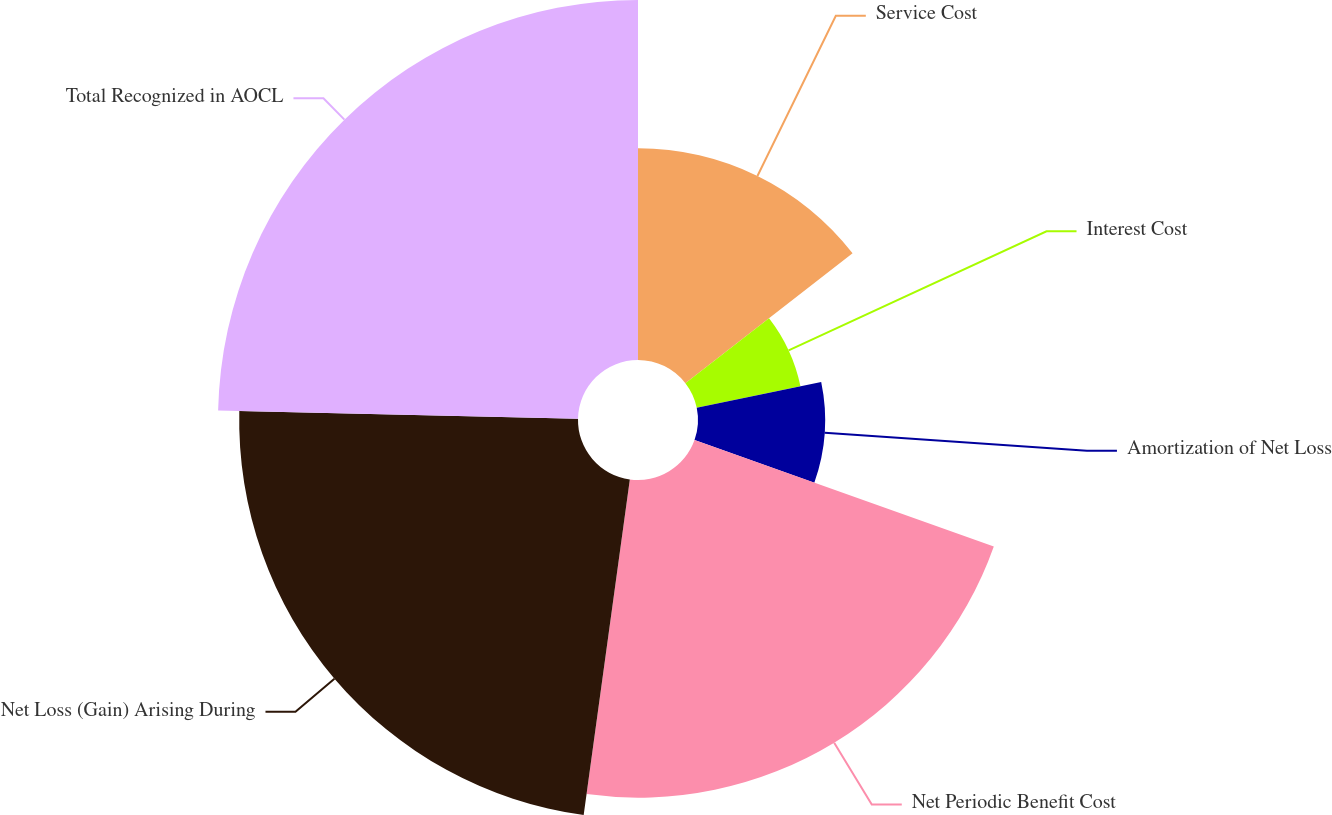Convert chart. <chart><loc_0><loc_0><loc_500><loc_500><pie_chart><fcel>Service Cost<fcel>Interest Cost<fcel>Amortization of Net Loss<fcel>Net Periodic Benefit Cost<fcel>Net Loss (Gain) Arising During<fcel>Total Recognized in AOCL<nl><fcel>14.49%<fcel>7.25%<fcel>8.7%<fcel>21.74%<fcel>23.19%<fcel>24.64%<nl></chart> 